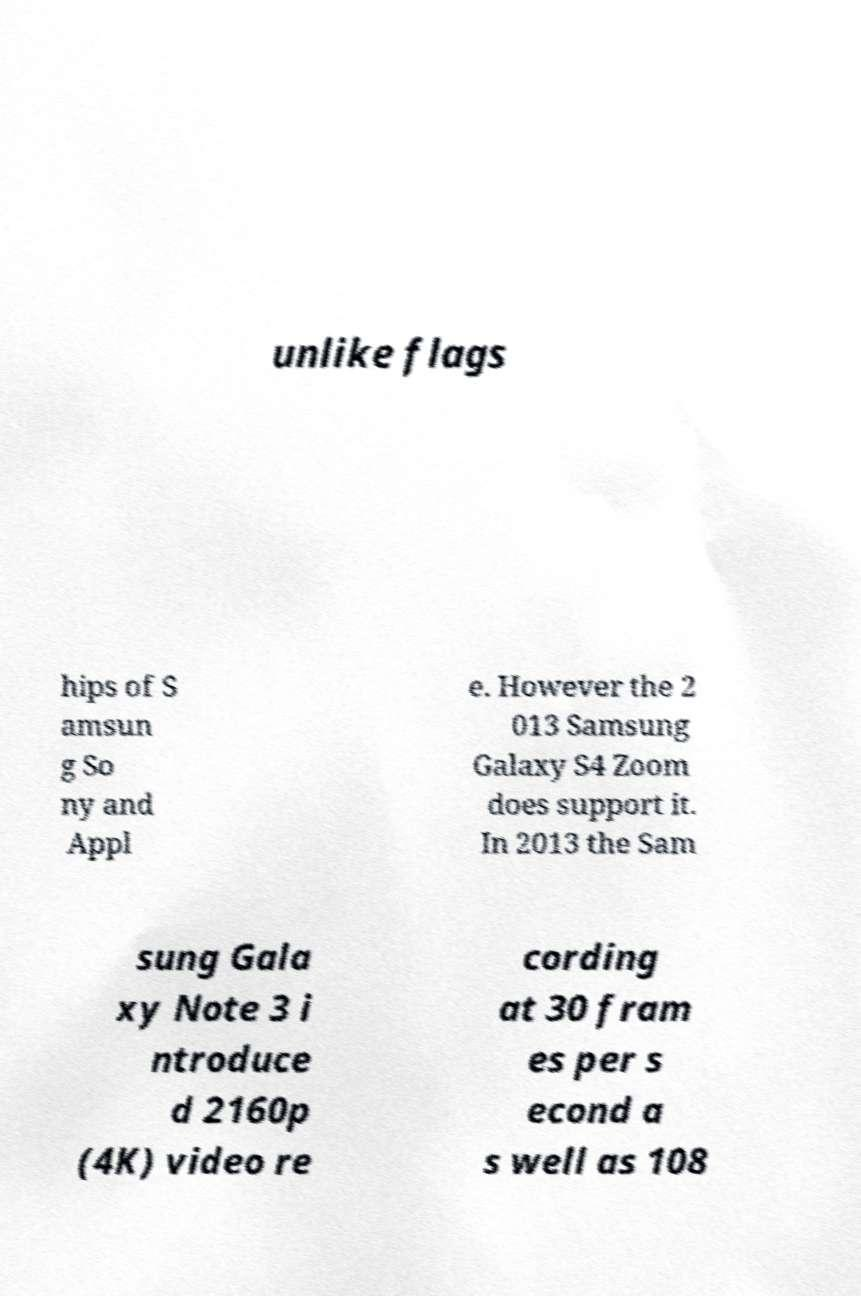I need the written content from this picture converted into text. Can you do that? unlike flags hips of S amsun g So ny and Appl e. However the 2 013 Samsung Galaxy S4 Zoom does support it. In 2013 the Sam sung Gala xy Note 3 i ntroduce d 2160p (4K) video re cording at 30 fram es per s econd a s well as 108 